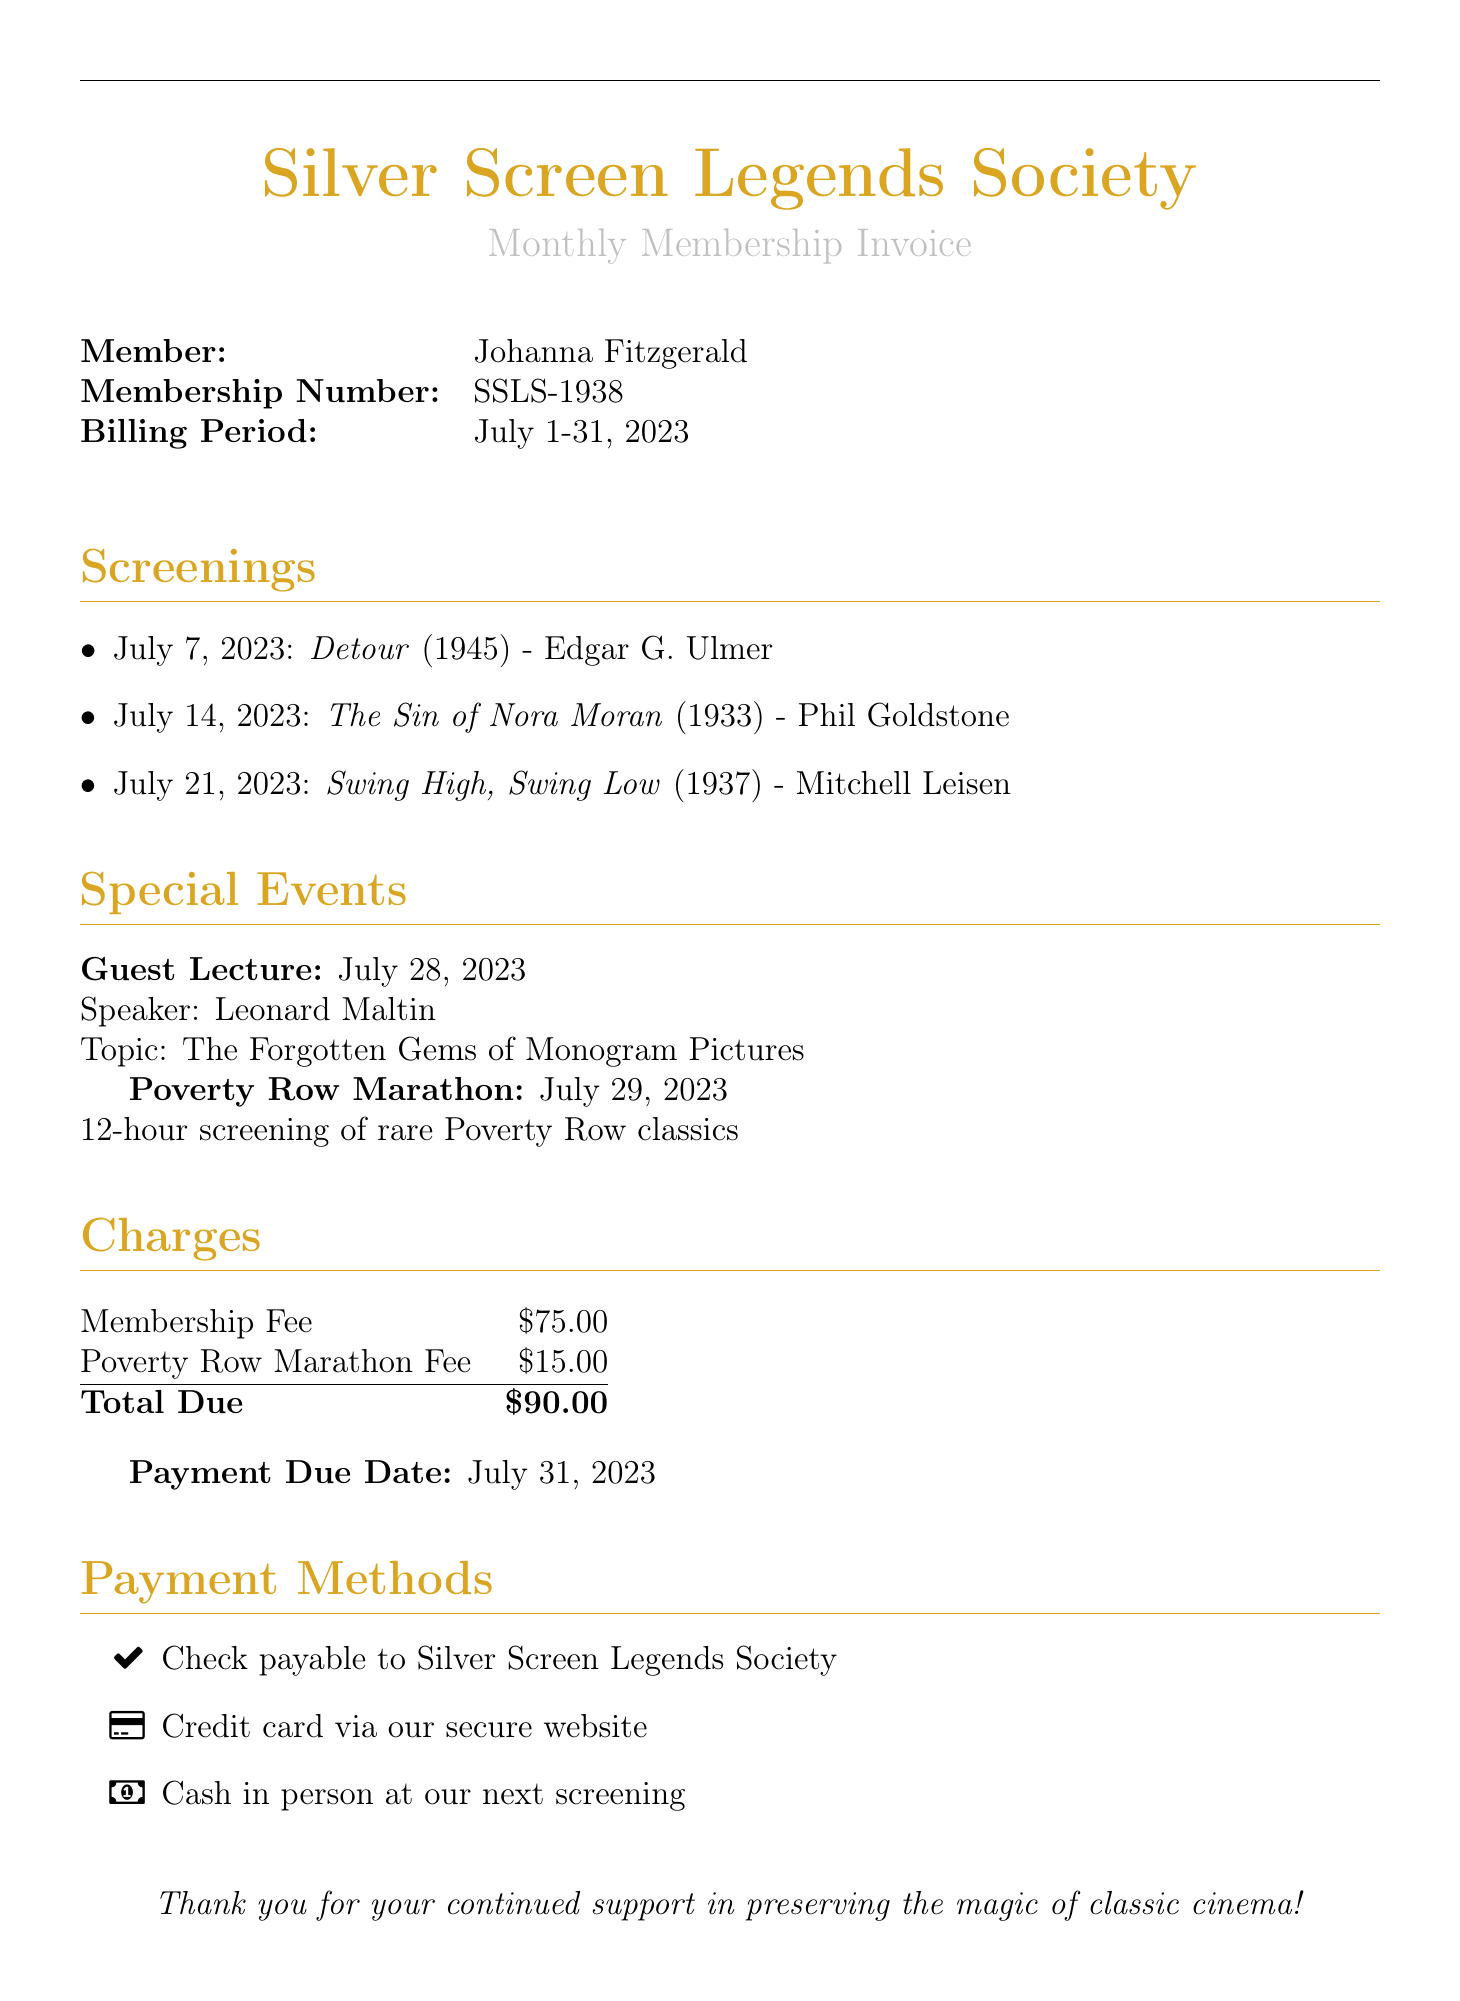What is the membership number? The membership number is listed in the document under the member's details.
Answer: SSLS-1938 When is the payment due date? The payment due date is mentioned in the last section of the document.
Answer: July 31, 2023 Who is the guest speaker for the special event? The guest speaker's name is provided in the special events section of the document.
Answer: Leonard Maltin What is the total amount due? The total amount due is calculated and displayed in the charges section of the document.
Answer: $90.00 How many screenings are listed in the document? The number of screenings can be counted from the list provided under the screenings section.
Answer: 3 What is the title of the film screened on July 14, 2023? The title of the film is found in the date-specific listings in the screenings section.
Answer: The Sin of Nora Moran Is there a fee for the Poverty Row Marathon? The document explicitly states if there's a fee for this special event.
Answer: $15.00 What type of document is this? The nature of the document is evident from the title and its layout.
Answer: Invoice 